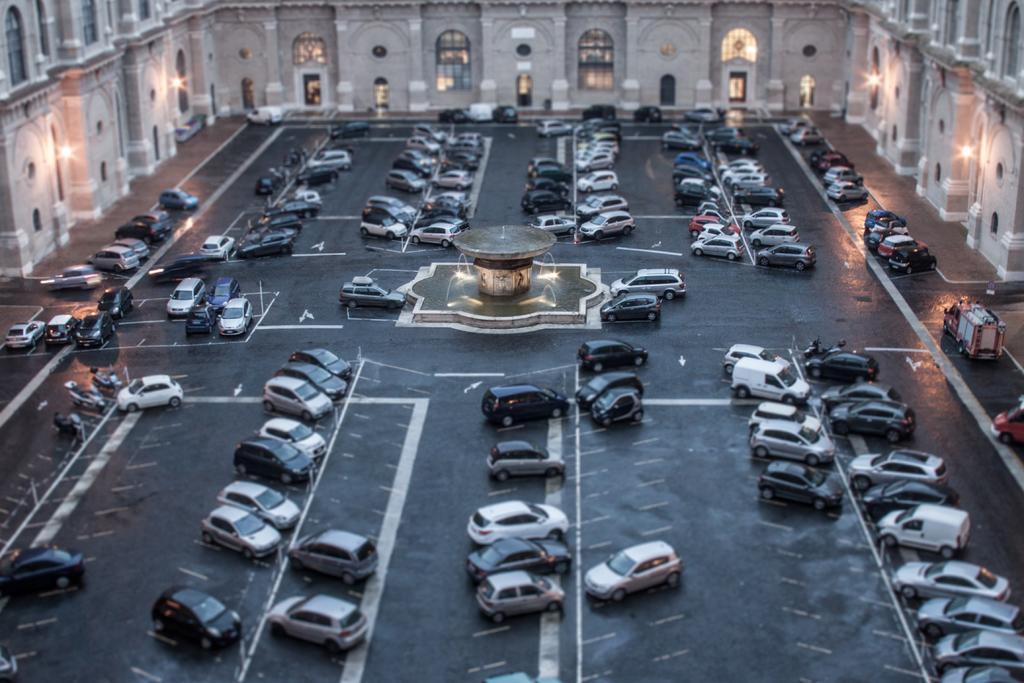How would you summarize this image in a sentence or two? In this picture there is a building. In the middle of the image there is a fountain and there are vehicles on the road and there are lights on the wall. 